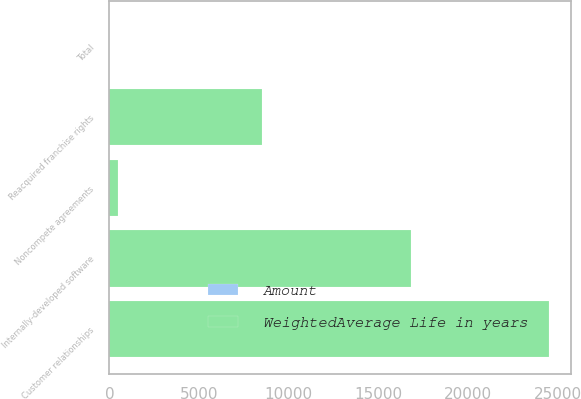<chart> <loc_0><loc_0><loc_500><loc_500><stacked_bar_chart><ecel><fcel>Reacquired franchise rights<fcel>Customer relationships<fcel>Internally-developed software<fcel>Noncompete agreements<fcel>Total<nl><fcel>WeightedAverage Life in years<fcel>8480<fcel>24518<fcel>16821<fcel>453<fcel>6<nl><fcel>Amount<fcel>5<fcel>6<fcel>2<fcel>5<fcel>4<nl></chart> 